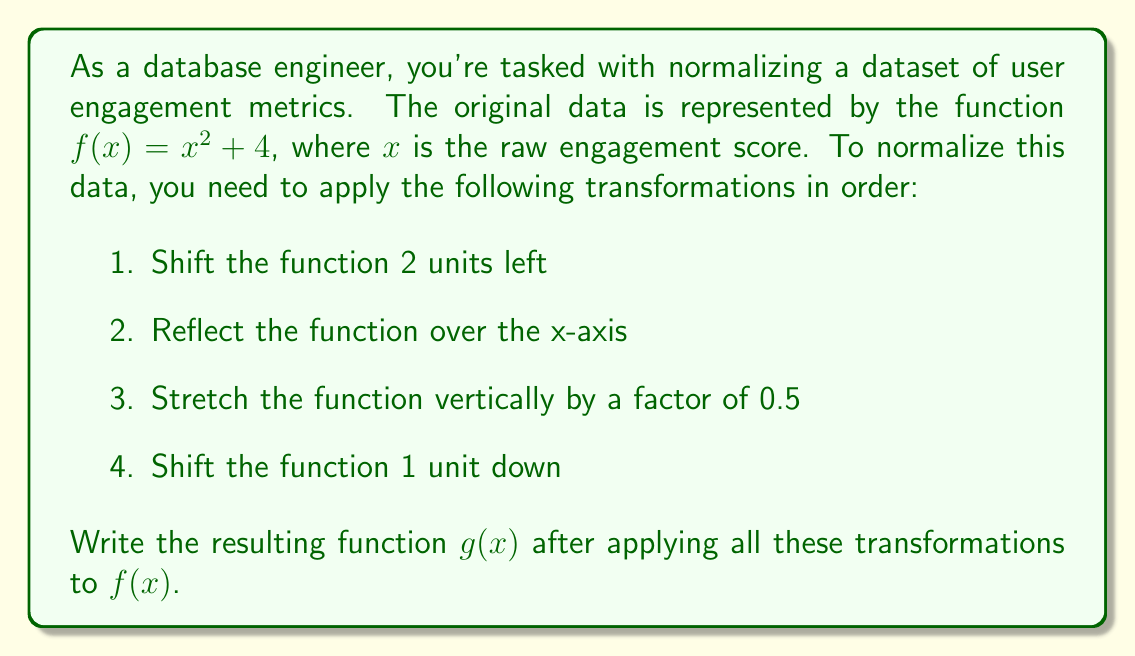Could you help me with this problem? Let's apply the transformations step by step:

1. Shift 2 units left: 
   $f_1(x) = (x+2)^2 + 4$

2. Reflect over the x-axis:
   $f_2(x) = -((x+2)^2 + 4)$

3. Stretch vertically by a factor of 0.5:
   $f_3(x) = -0.5((x+2)^2 + 4)$

4. Shift 1 unit down:
   $g(x) = f_4(x) = -0.5((x+2)^2 + 4) - 1$

Now, let's simplify the final function:

$$\begin{aligned}
g(x) &= -0.5((x+2)^2 + 4) - 1 \\
&= -0.5(x^2 + 4x + 4 + 4) - 1 \\
&= -0.5(x^2 + 4x + 8) - 1 \\
&= -0.5x^2 - 2x - 4 - 1 \\
&= -0.5x^2 - 2x - 5
\end{aligned}$$

Therefore, the final normalized function is $g(x) = -0.5x^2 - 2x - 5$.
Answer: $g(x) = -0.5x^2 - 2x - 5$ 